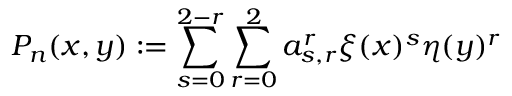Convert formula to latex. <formula><loc_0><loc_0><loc_500><loc_500>P _ { n } ( x , y ) \colon = \sum _ { s = 0 } ^ { 2 - r } \sum _ { r = 0 } ^ { 2 } a _ { s , r } ^ { r } \xi ( x ) ^ { s } \eta ( y ) ^ { r }</formula> 